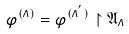<formula> <loc_0><loc_0><loc_500><loc_500>\varphi ^ { ( \Lambda ) } = \varphi ^ { ( \Lambda ^ { ^ { \prime } } ) } \upharpoonright { \mathfrak A } _ { \Lambda }</formula> 